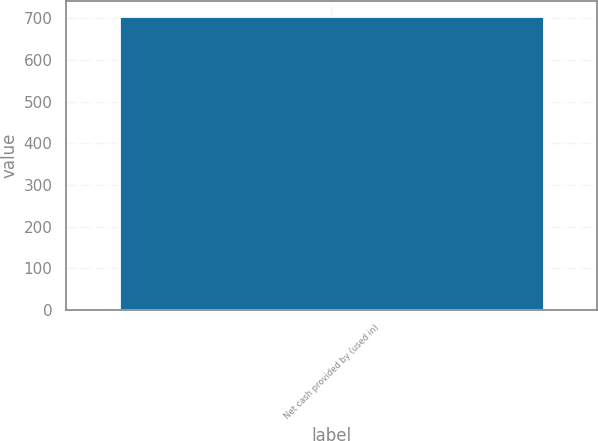Convert chart. <chart><loc_0><loc_0><loc_500><loc_500><bar_chart><fcel>Net cash provided by (used in)<nl><fcel>706<nl></chart> 